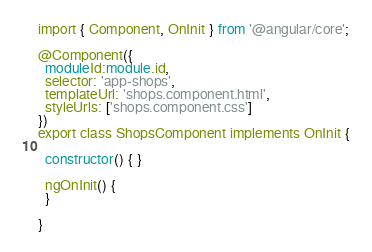Convert code to text. <code><loc_0><loc_0><loc_500><loc_500><_TypeScript_>import { Component, OnInit } from '@angular/core';

@Component({
  moduleId:module.id,
  selector: 'app-shops',
  templateUrl: 'shops.component.html',
  styleUrls: ['shops.component.css']
})
export class ShopsComponent implements OnInit {

  constructor() { }

  ngOnInit() {
  }

}</code> 